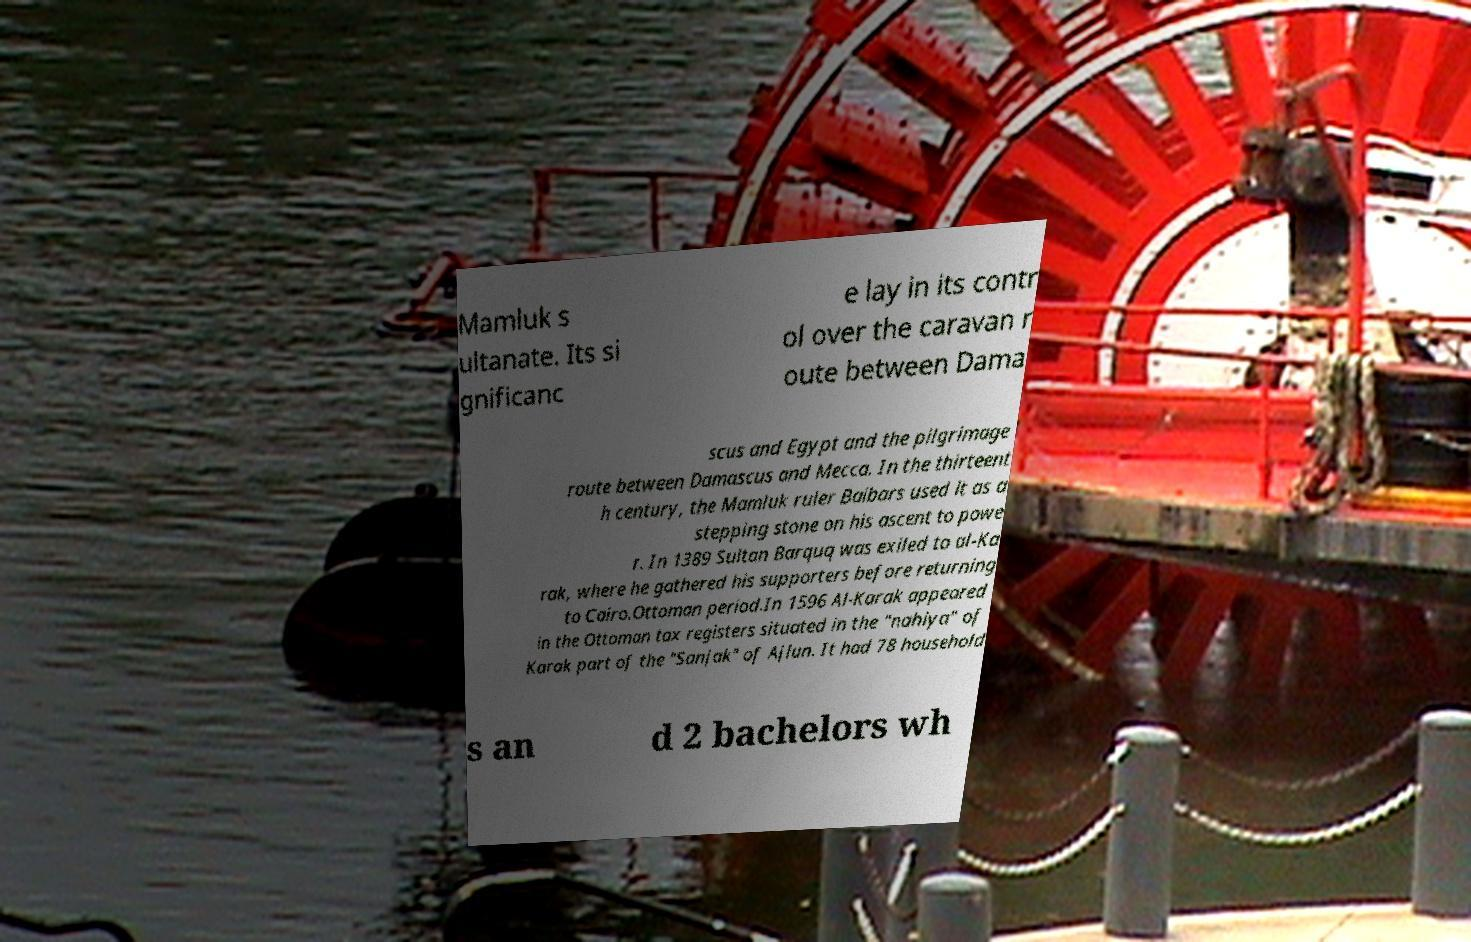Can you accurately transcribe the text from the provided image for me? Mamluk s ultanate. Its si gnificanc e lay in its contr ol over the caravan r oute between Dama scus and Egypt and the pilgrimage route between Damascus and Mecca. In the thirteent h century, the Mamluk ruler Baibars used it as a stepping stone on his ascent to powe r. In 1389 Sultan Barquq was exiled to al-Ka rak, where he gathered his supporters before returning to Cairo.Ottoman period.In 1596 Al-Karak appeared in the Ottoman tax registers situated in the "nahiya" of Karak part of the "Sanjak" of Ajlun. It had 78 household s an d 2 bachelors wh 